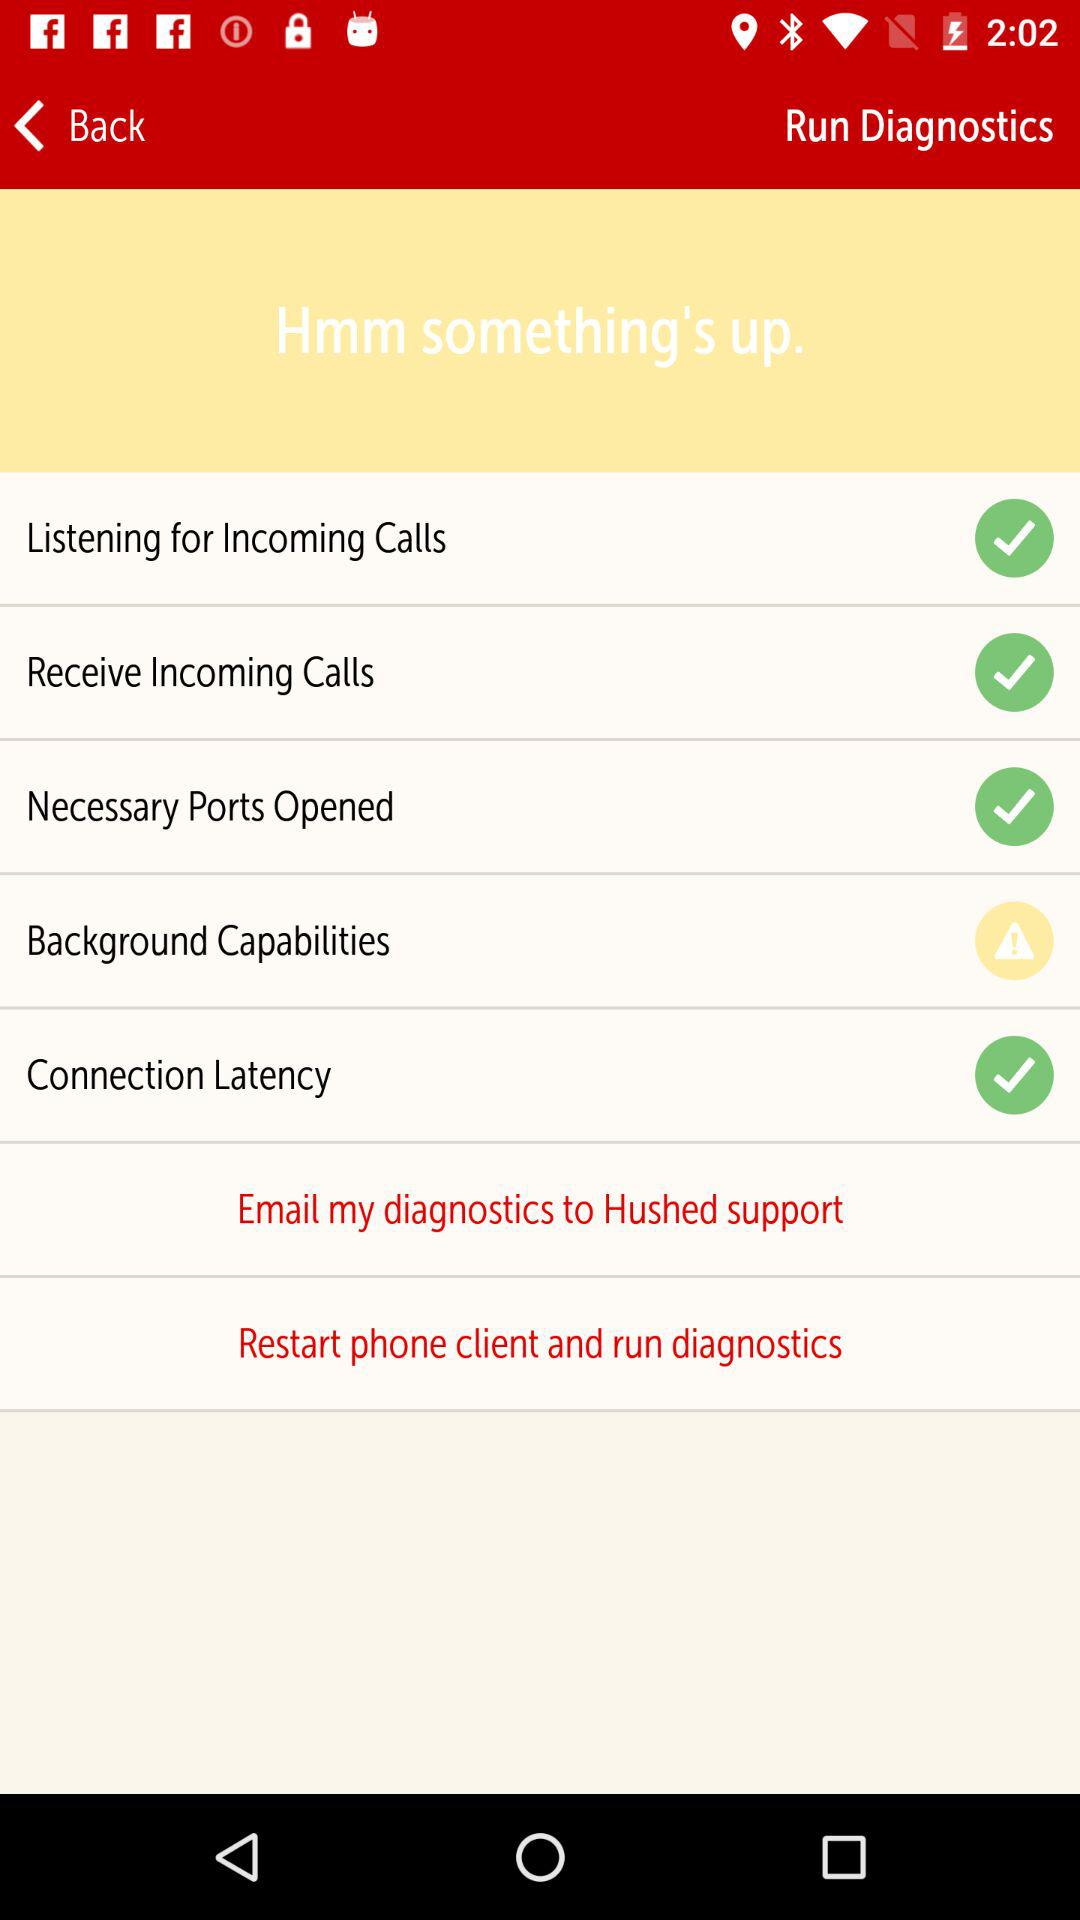Which option has an error? The option is "Background Capabilities". 